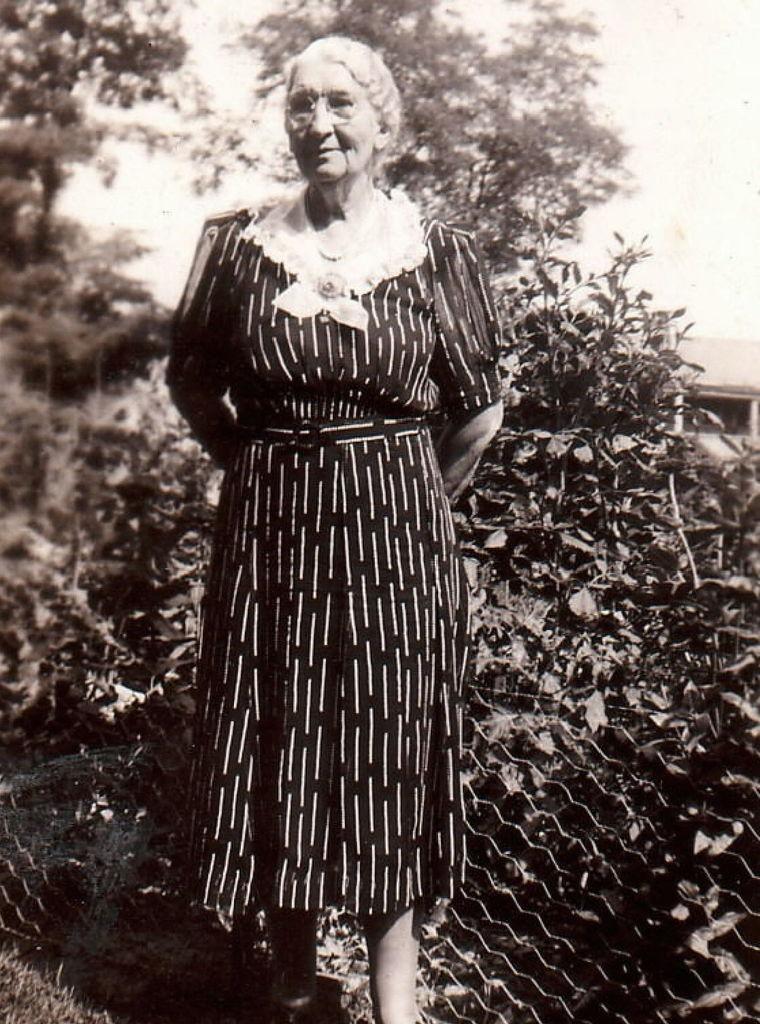In one or two sentences, can you explain what this image depicts? In this image I can see the person is standing. I can see few trees, sky and the net fencing. 